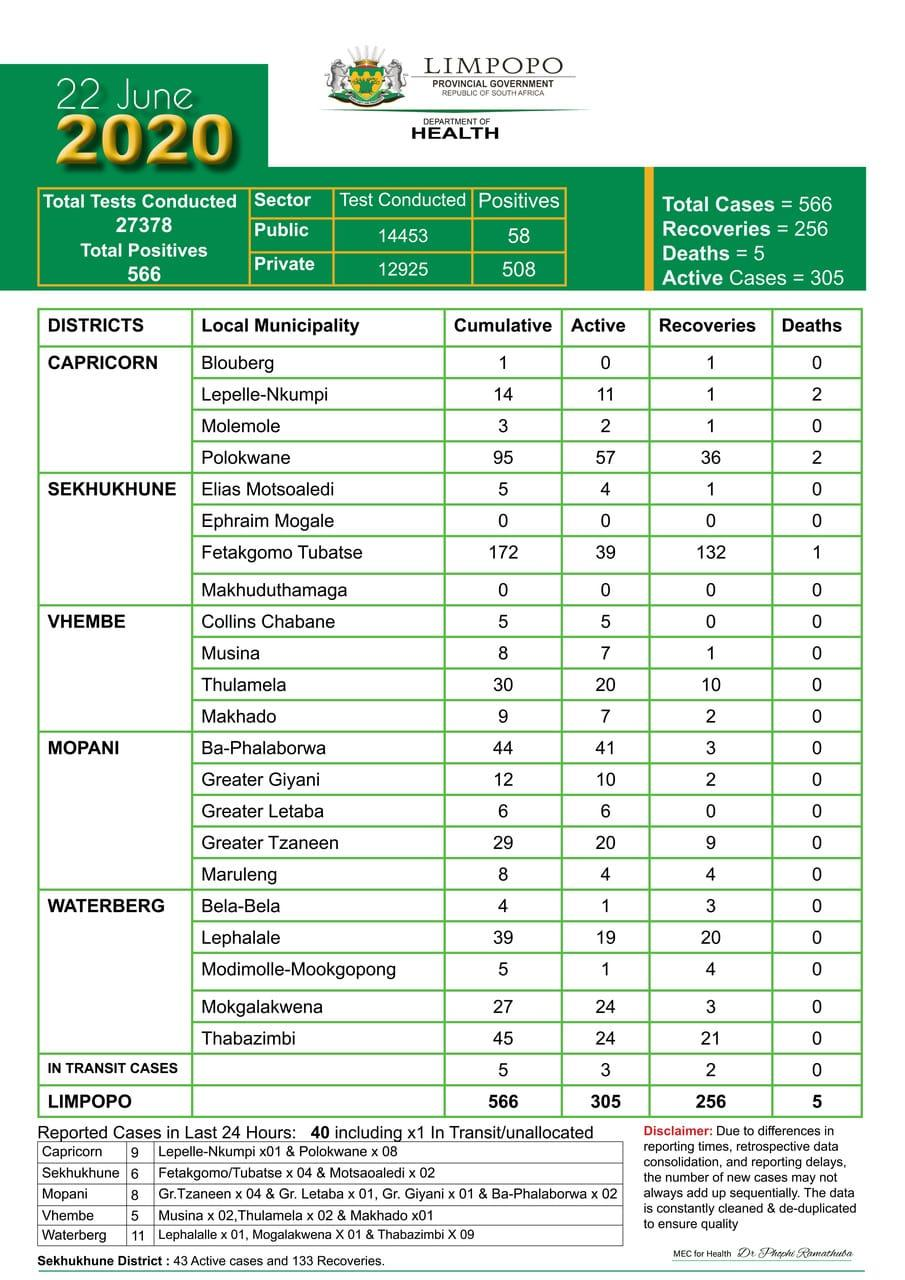Draw attention to some important aspects in this diagram. In the last 24 hours, out of the 11 cases reported in Waterberg, 10 cases were reported in Laphalalle and Thabazimbi. The recovery of Blouberg has been significant, with a reported 100% recovery. In the municipality of Lepelle-Nkumpi and Polokwane, a total of two deaths have been reported. Other than Vhembe, where no deaths were reported, Mopani and Waterberg districts also did not record any fatalities during the specified period, According to the report, 19 municipalities have a total death count of 0. 